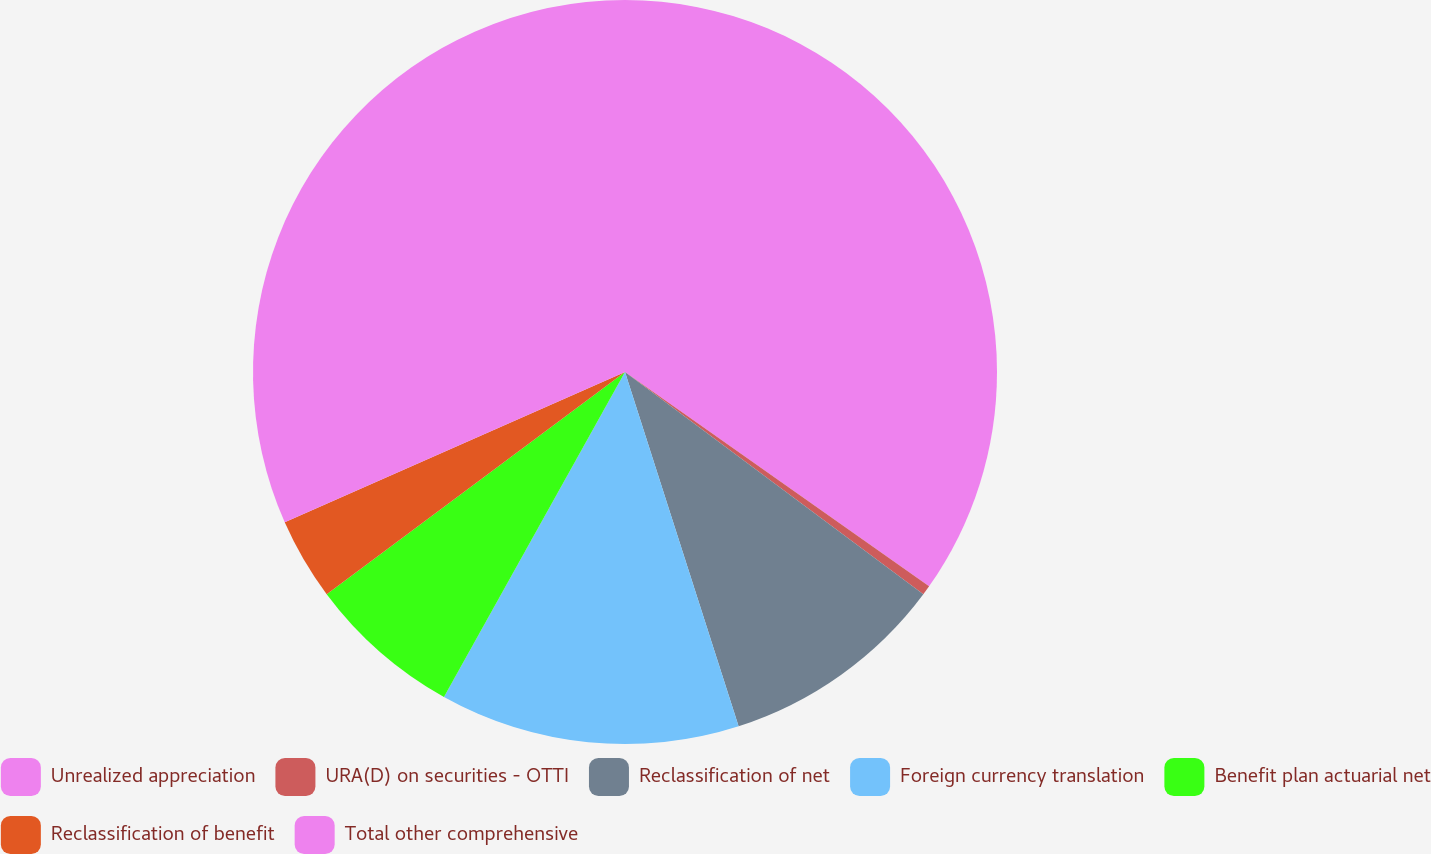Convert chart. <chart><loc_0><loc_0><loc_500><loc_500><pie_chart><fcel>Unrealized appreciation<fcel>URA(D) on securities - OTTI<fcel>Reclassification of net<fcel>Foreign currency translation<fcel>Benefit plan actuarial net<fcel>Reclassification of benefit<fcel>Total other comprehensive<nl><fcel>34.77%<fcel>0.42%<fcel>9.87%<fcel>13.03%<fcel>6.72%<fcel>3.57%<fcel>31.62%<nl></chart> 